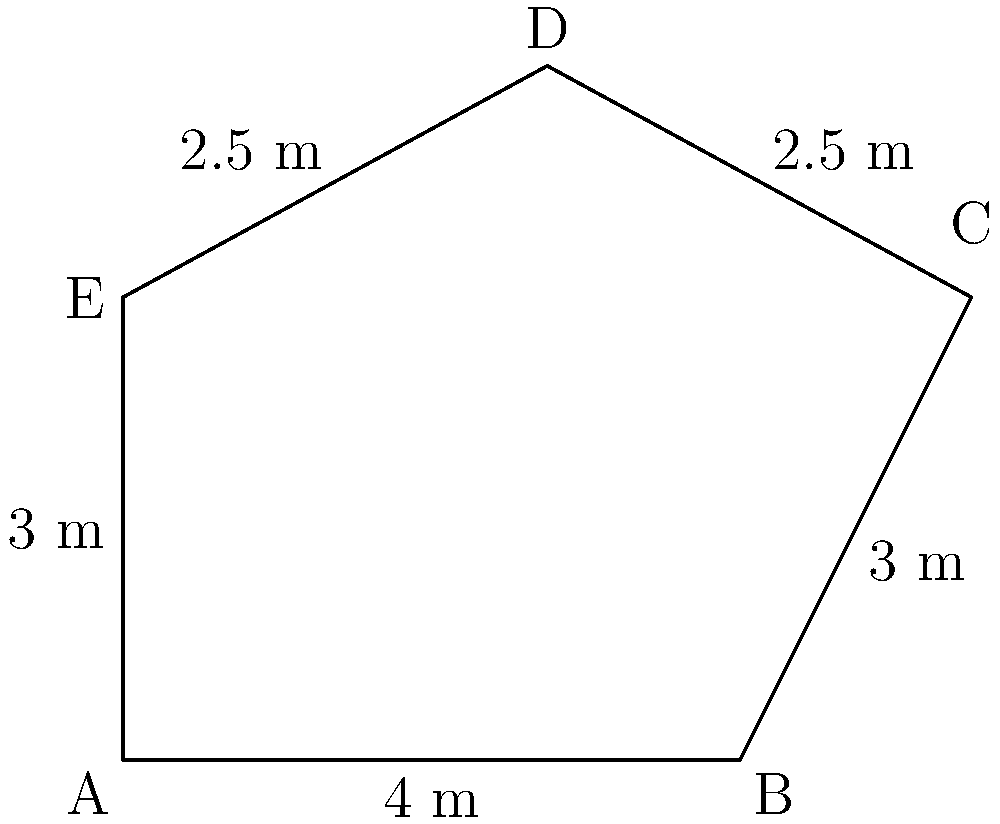In your introspective writing space, you have a pentagonal room as shown in the diagram. If the room's dimensions are as indicated, what is the area of this unique writing sanctuary? To find the area of the pentagonal room, we can divide it into simpler shapes and sum their areas. Let's break it down step-by-step:

1) First, let's divide the pentagon into a rectangle and a triangle.

2) The rectangle:
   Width = 4 m
   Height = 3 m
   Area of rectangle = $4 \times 3 = 12$ m²

3) The triangle:
   Base = 1.5 m (5.5 m - 4 m)
   Height = 1.5 m (4.5 m - 3 m)
   Area of triangle = $\frac{1}{2} \times 1.5 \times 1.5 = 1.125$ m²

4) Total area:
   Area of pentagon = Area of rectangle + Area of triangle
                    = $12 + 1.125 = 13.125$ m²

Therefore, the area of your introspective writing space is 13.125 square meters.
Answer: $13.125$ m² 